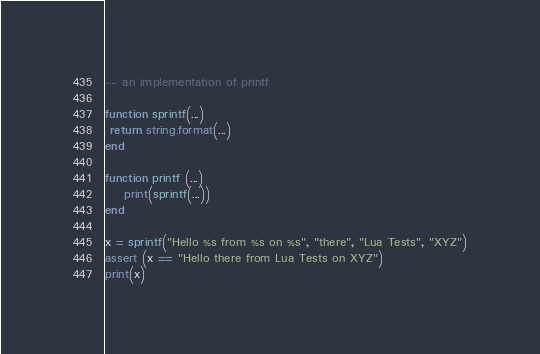<code> <loc_0><loc_0><loc_500><loc_500><_Lua_>-- an implementation of printf

function sprintf(...)
 return string.format(...)
end

function printf (...)
	print(sprintf(...))
end

x = sprintf("Hello %s from %s on %s", "there", "Lua Tests", "XYZ")
assert (x == "Hello there from Lua Tests on XYZ")
print(x)
</code> 